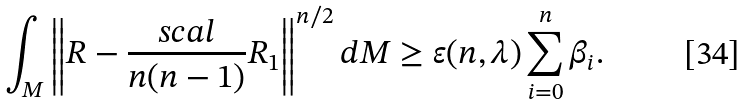<formula> <loc_0><loc_0><loc_500><loc_500>\int _ { M } \left \| R - \frac { s c a l } { n ( n - 1 ) } R _ { 1 } \right \| ^ { n / 2 } d M \geq \varepsilon ( n , \lambda ) \sum _ { i = 0 } ^ { n } \beta _ { i } .</formula> 